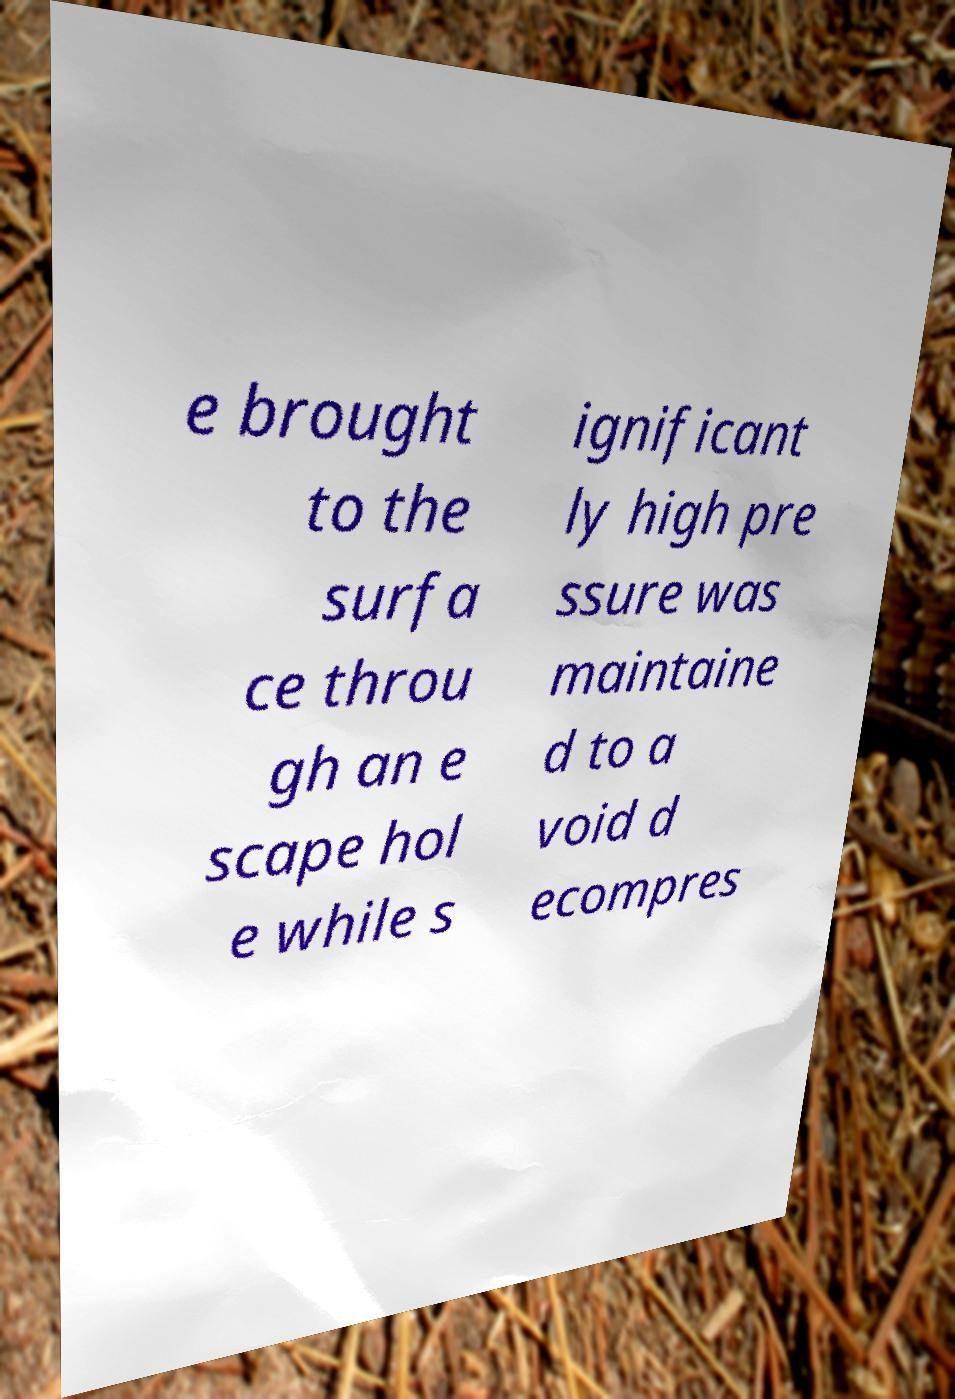What messages or text are displayed in this image? I need them in a readable, typed format. e brought to the surfa ce throu gh an e scape hol e while s ignificant ly high pre ssure was maintaine d to a void d ecompres 